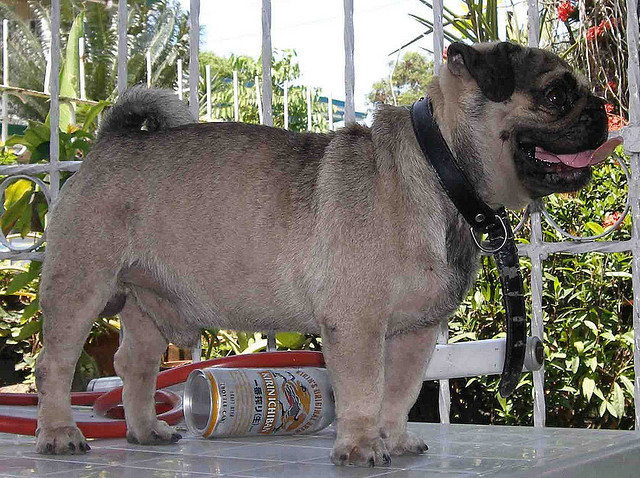<image>What is in the can? I am not sure what is in the can. However, it might be beer. What is in the can? I don't know what is in the can. It seems like it contains beer. 